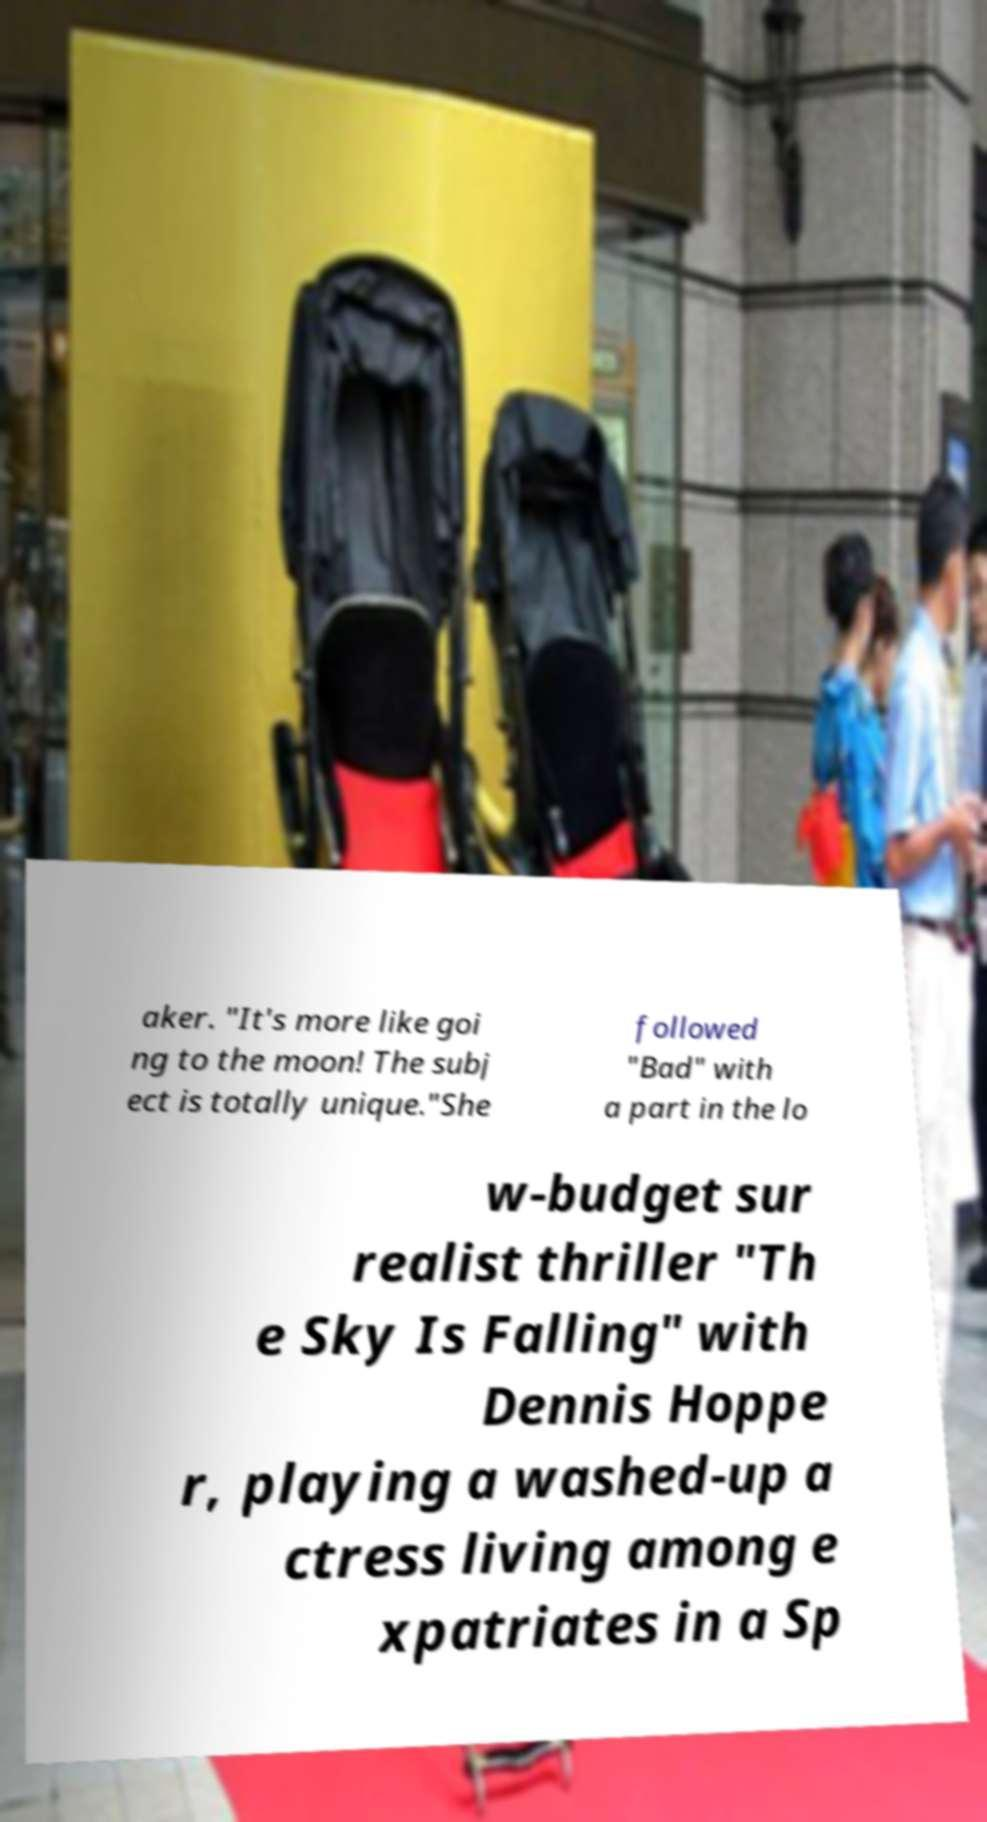Please read and relay the text visible in this image. What does it say? aker. "It's more like goi ng to the moon! The subj ect is totally unique."She followed "Bad" with a part in the lo w-budget sur realist thriller "Th e Sky Is Falling" with Dennis Hoppe r, playing a washed-up a ctress living among e xpatriates in a Sp 